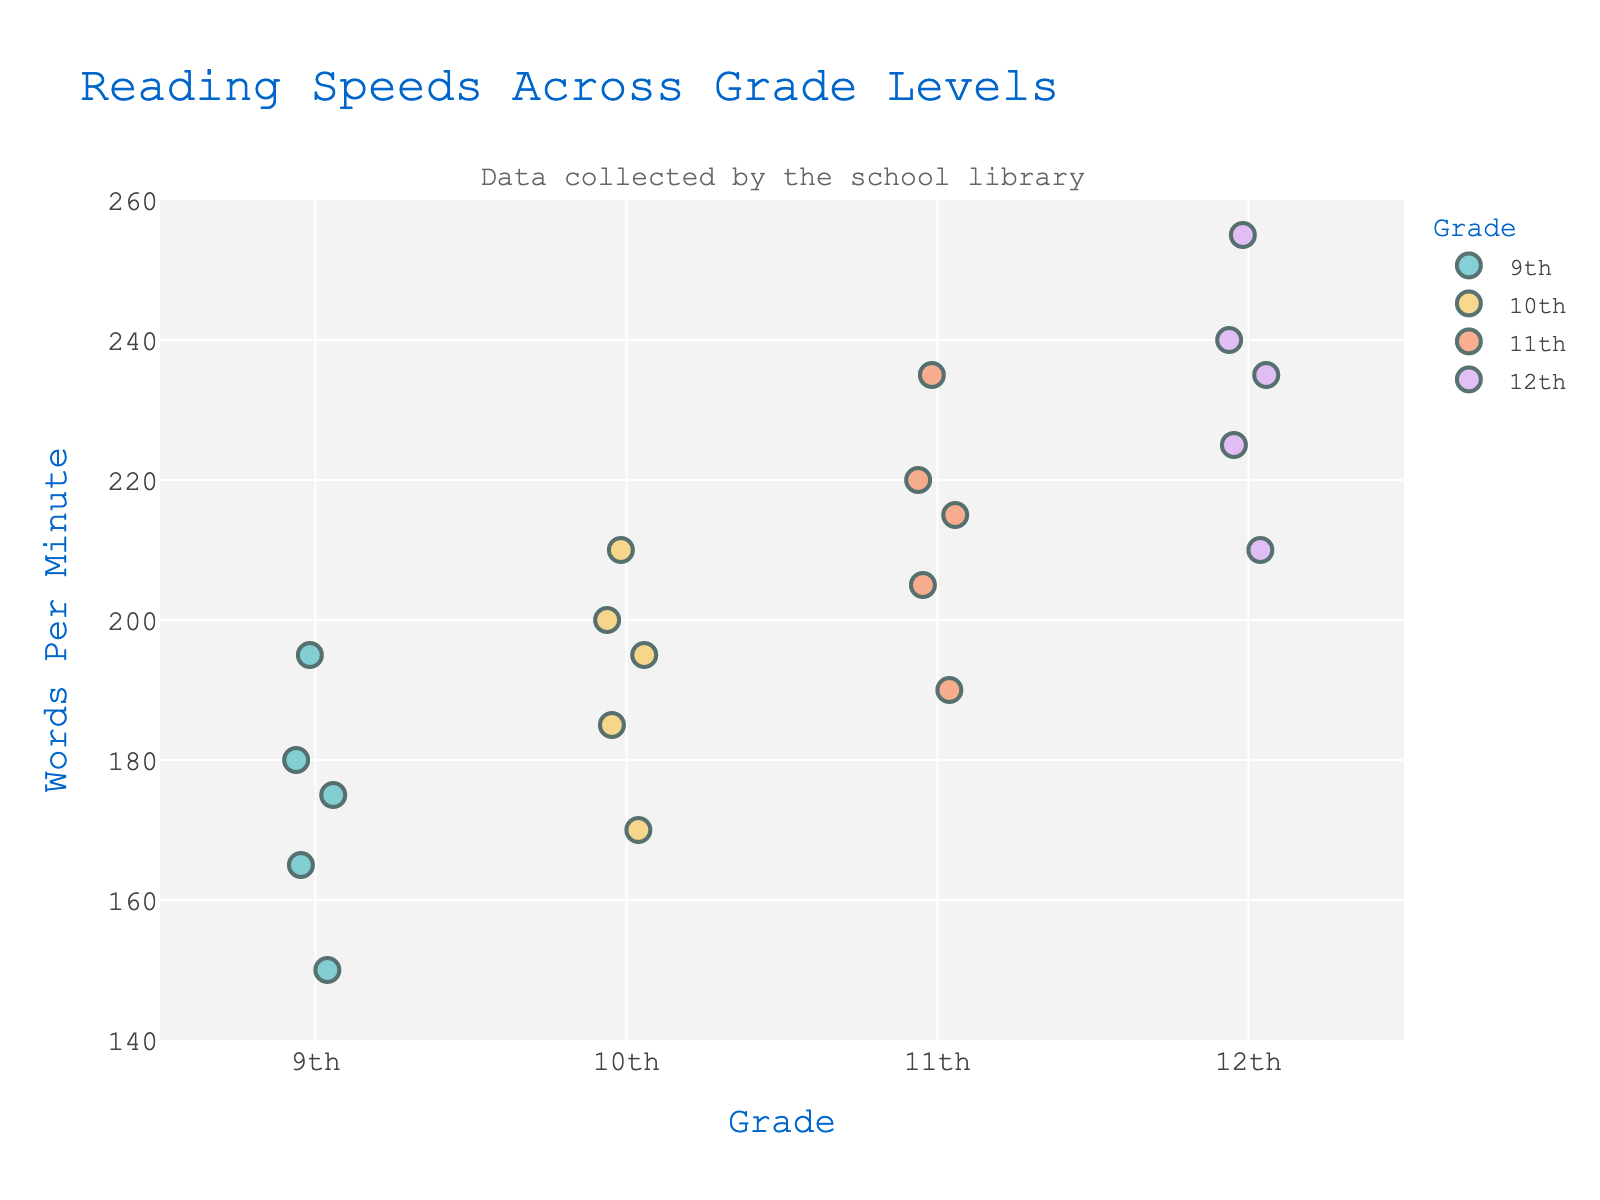how many grade levels are represented in the plot? There are different grades clearly marked on the x-axis, which represent the groups. By counting these unique markers, we can see that the grades represented are 9th, 10th, 11th, and 12th.
Answer: 4 what is the title of the plot? The title is displayed at the top of the figure. It succinctly describes the main topic of the data being visualized.
Answer: reading speeds across grade levels which grade has the highest range of reading speeds? By closely examining the spread of the data points (dots) in the plot, we notice that the gaps between the highest and lowest points vary. Observing each grade, the 12th grade has the data points from the lowest to the highest values with a wider spread compared to the others.
Answer: 12th what is the average reading speed for 11th graders? To calculate the average, we first identify the reading speeds of 11th graders (220, 205, 235, 190, 215). Adding these values gives us a total of 1065. We then divide by the number of data points (5).
Answer: 213 how does the reading speed of the fastest 9th grader compare to the slowest 12th grader? We look at the highest point for 9th graders and the lowest point for 12th graders based on the y-axis values. The fastest 9th grader reads at 195 words per minute, while the slowest 12th grader reads at 210 words per minute. Thus, the slowest 12th grader reads faster than the fastest 9th grader.
Answer: 12th grader is faster which grade has the most clustered data points? By examining the density of the points around a central value, we can determine which grade has the most tightly packed data. The 10th grade has reading speeds that are more closely grouped together compared to other grades.
Answer: 10th what is the total number of data points in the plot? By summing the data points for each grade, we can find the total number. Each grade has 5 points, making a total of 20 data points.
Answer: 20 what is the difference between the highest reading speed of 12th graders and the lowest reading speed of 9th graders? First, find the highest reading speed for 12th graders, which is 255 words per minute, and the lowest reading speed for 9th graders, which is 150 words per minute. The difference between these two values is 255 - 150.
Answer: 105 what does the subtitle indicate? The subtitle is located just below the main title and provides additional context about the source of the data. In this case, it tells us that the data was collected by the school library.
Answer: data collected by the school library how does the median reading speed for 10th graders compare to the median for 11th graders? First, find the median values for both groups. For 10th graders, the median is the middle value of (170, 185, 195, 200, 210), which is 195. For 11th graders, the median is the middle value of (190, 205, 215, 220, 235), which is 215. Comparing these two medians, the median reading speed for 11th graders is higher.
Answer: 11th graders is higher 